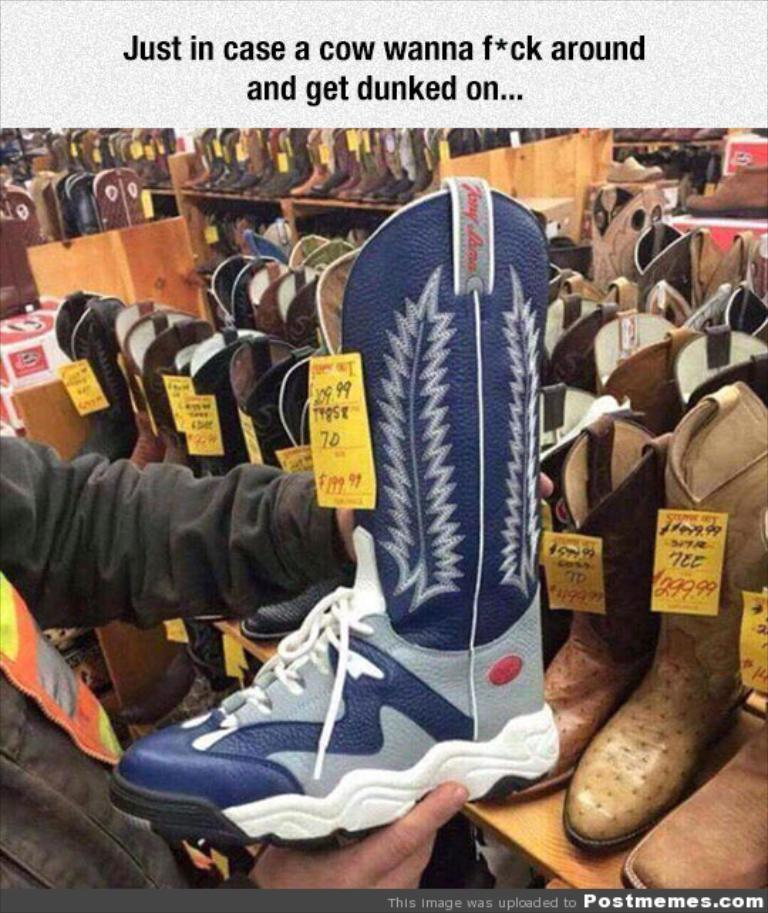What is the person in the image holding? The person is holding a shoe in the image. What can be seen on the racks in the image? There are racks with boots and shoes in the image. How can the prices of the boots and shoes be identified? Price tags are present on the boots and shoes. What type of business is being conducted in the image? There is no indication of a business being conducted in the image; it simply shows a person holding a shoe and racks with boots and shoes. Can you compare the prices of the boots and shoes in the image? The conversation does not include any information about the prices of the boots and shoes, so it is not possible to compare them. 